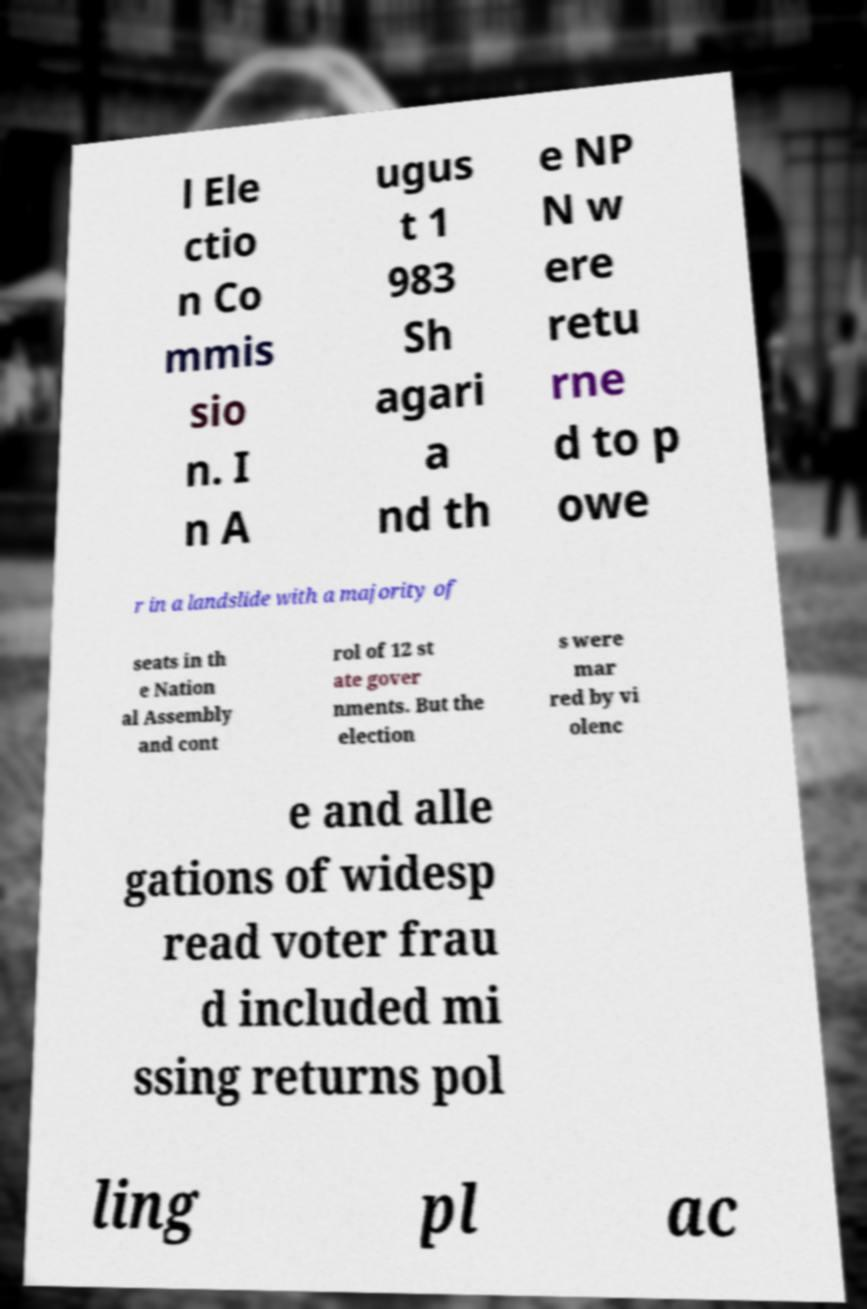I need the written content from this picture converted into text. Can you do that? l Ele ctio n Co mmis sio n. I n A ugus t 1 983 Sh agari a nd th e NP N w ere retu rne d to p owe r in a landslide with a majority of seats in th e Nation al Assembly and cont rol of 12 st ate gover nments. But the election s were mar red by vi olenc e and alle gations of widesp read voter frau d included mi ssing returns pol ling pl ac 